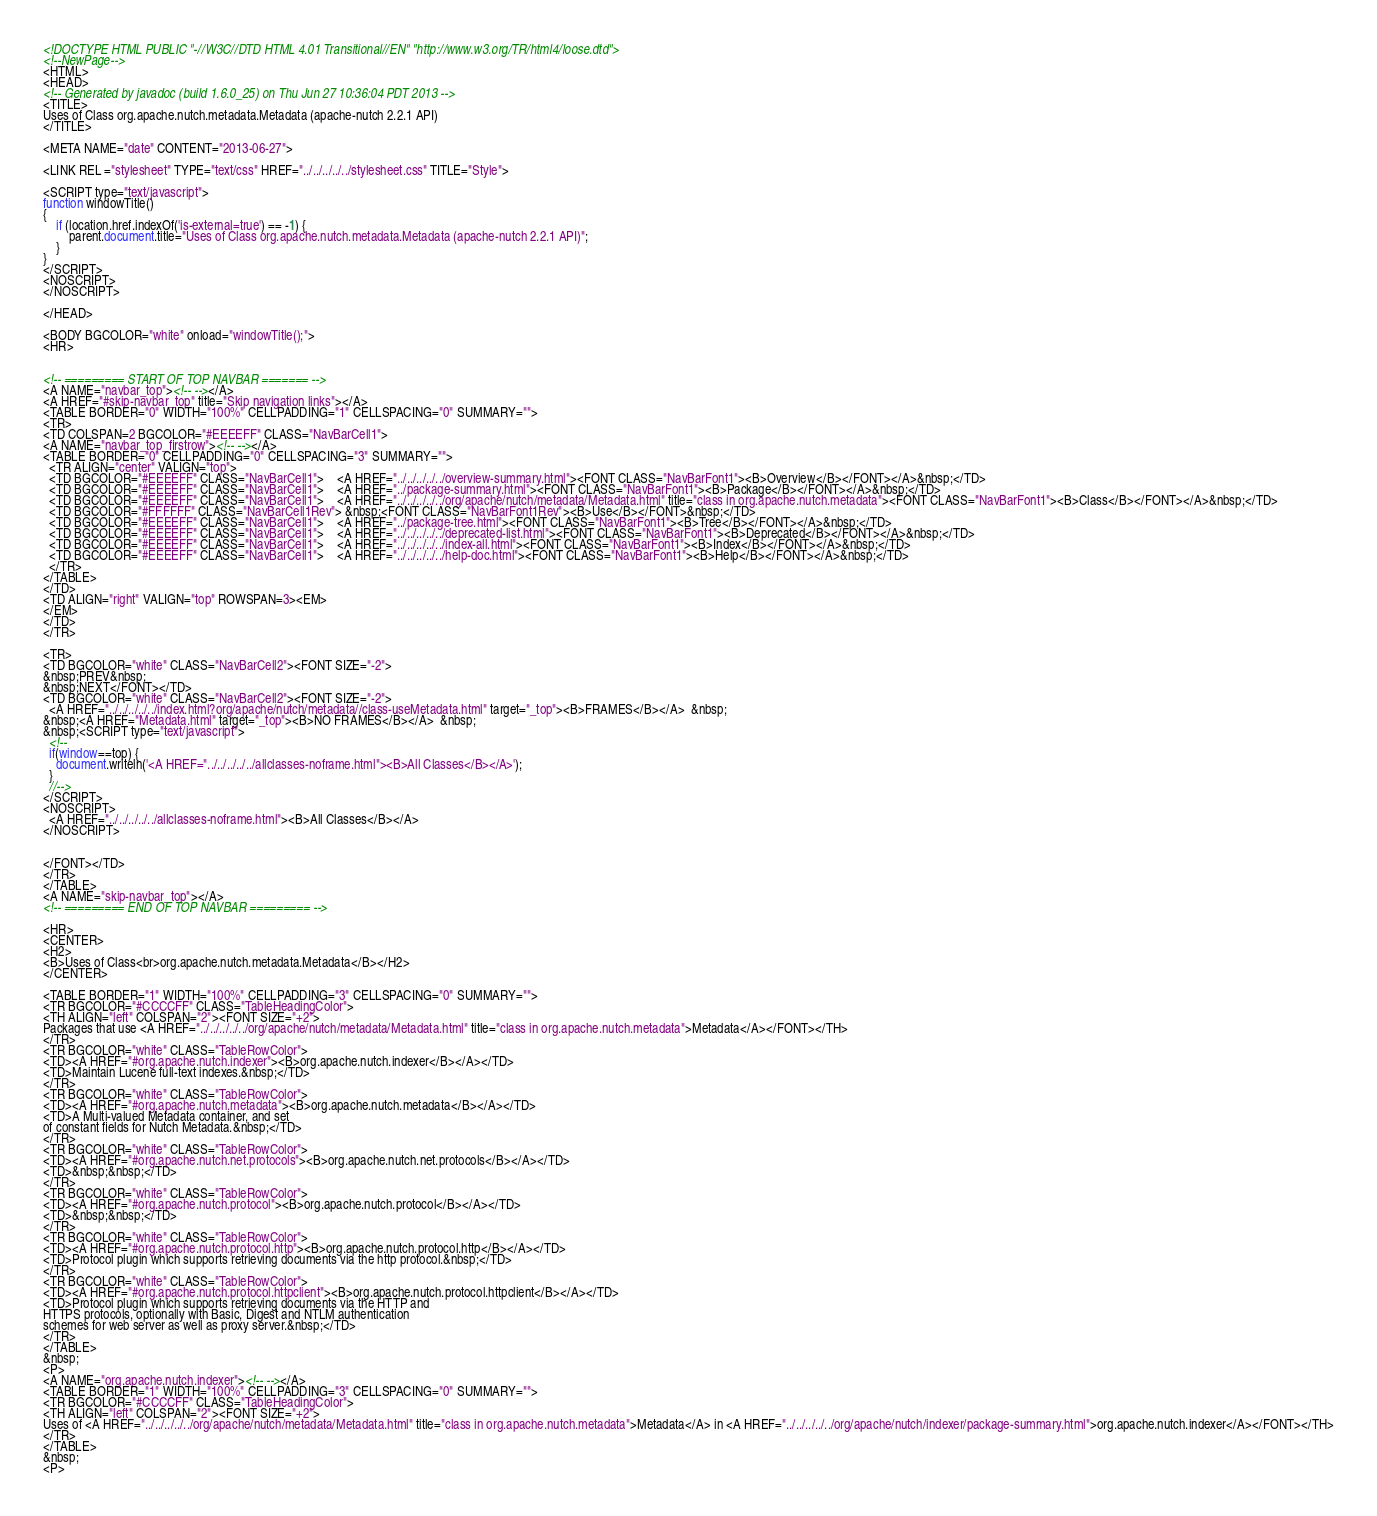<code> <loc_0><loc_0><loc_500><loc_500><_HTML_><!DOCTYPE HTML PUBLIC "-//W3C//DTD HTML 4.01 Transitional//EN" "http://www.w3.org/TR/html4/loose.dtd">
<!--NewPage-->
<HTML>
<HEAD>
<!-- Generated by javadoc (build 1.6.0_25) on Thu Jun 27 10:36:04 PDT 2013 -->
<TITLE>
Uses of Class org.apache.nutch.metadata.Metadata (apache-nutch 2.2.1 API)
</TITLE>

<META NAME="date" CONTENT="2013-06-27">

<LINK REL ="stylesheet" TYPE="text/css" HREF="../../../../../stylesheet.css" TITLE="Style">

<SCRIPT type="text/javascript">
function windowTitle()
{
    if (location.href.indexOf('is-external=true') == -1) {
        parent.document.title="Uses of Class org.apache.nutch.metadata.Metadata (apache-nutch 2.2.1 API)";
    }
}
</SCRIPT>
<NOSCRIPT>
</NOSCRIPT>

</HEAD>

<BODY BGCOLOR="white" onload="windowTitle();">
<HR>


<!-- ========= START OF TOP NAVBAR ======= -->
<A NAME="navbar_top"><!-- --></A>
<A HREF="#skip-navbar_top" title="Skip navigation links"></A>
<TABLE BORDER="0" WIDTH="100%" CELLPADDING="1" CELLSPACING="0" SUMMARY="">
<TR>
<TD COLSPAN=2 BGCOLOR="#EEEEFF" CLASS="NavBarCell1">
<A NAME="navbar_top_firstrow"><!-- --></A>
<TABLE BORDER="0" CELLPADDING="0" CELLSPACING="3" SUMMARY="">
  <TR ALIGN="center" VALIGN="top">
  <TD BGCOLOR="#EEEEFF" CLASS="NavBarCell1">    <A HREF="../../../../../overview-summary.html"><FONT CLASS="NavBarFont1"><B>Overview</B></FONT></A>&nbsp;</TD>
  <TD BGCOLOR="#EEEEFF" CLASS="NavBarCell1">    <A HREF="../package-summary.html"><FONT CLASS="NavBarFont1"><B>Package</B></FONT></A>&nbsp;</TD>
  <TD BGCOLOR="#EEEEFF" CLASS="NavBarCell1">    <A HREF="../../../../../org/apache/nutch/metadata/Metadata.html" title="class in org.apache.nutch.metadata"><FONT CLASS="NavBarFont1"><B>Class</B></FONT></A>&nbsp;</TD>
  <TD BGCOLOR="#FFFFFF" CLASS="NavBarCell1Rev"> &nbsp;<FONT CLASS="NavBarFont1Rev"><B>Use</B></FONT>&nbsp;</TD>
  <TD BGCOLOR="#EEEEFF" CLASS="NavBarCell1">    <A HREF="../package-tree.html"><FONT CLASS="NavBarFont1"><B>Tree</B></FONT></A>&nbsp;</TD>
  <TD BGCOLOR="#EEEEFF" CLASS="NavBarCell1">    <A HREF="../../../../../deprecated-list.html"><FONT CLASS="NavBarFont1"><B>Deprecated</B></FONT></A>&nbsp;</TD>
  <TD BGCOLOR="#EEEEFF" CLASS="NavBarCell1">    <A HREF="../../../../../index-all.html"><FONT CLASS="NavBarFont1"><B>Index</B></FONT></A>&nbsp;</TD>
  <TD BGCOLOR="#EEEEFF" CLASS="NavBarCell1">    <A HREF="../../../../../help-doc.html"><FONT CLASS="NavBarFont1"><B>Help</B></FONT></A>&nbsp;</TD>
  </TR>
</TABLE>
</TD>
<TD ALIGN="right" VALIGN="top" ROWSPAN=3><EM>
</EM>
</TD>
</TR>

<TR>
<TD BGCOLOR="white" CLASS="NavBarCell2"><FONT SIZE="-2">
&nbsp;PREV&nbsp;
&nbsp;NEXT</FONT></TD>
<TD BGCOLOR="white" CLASS="NavBarCell2"><FONT SIZE="-2">
  <A HREF="../../../../../index.html?org/apache/nutch/metadata//class-useMetadata.html" target="_top"><B>FRAMES</B></A>  &nbsp;
&nbsp;<A HREF="Metadata.html" target="_top"><B>NO FRAMES</B></A>  &nbsp;
&nbsp;<SCRIPT type="text/javascript">
  <!--
  if(window==top) {
    document.writeln('<A HREF="../../../../../allclasses-noframe.html"><B>All Classes</B></A>');
  }
  //-->
</SCRIPT>
<NOSCRIPT>
  <A HREF="../../../../../allclasses-noframe.html"><B>All Classes</B></A>
</NOSCRIPT>


</FONT></TD>
</TR>
</TABLE>
<A NAME="skip-navbar_top"></A>
<!-- ========= END OF TOP NAVBAR ========= -->

<HR>
<CENTER>
<H2>
<B>Uses of Class<br>org.apache.nutch.metadata.Metadata</B></H2>
</CENTER>

<TABLE BORDER="1" WIDTH="100%" CELLPADDING="3" CELLSPACING="0" SUMMARY="">
<TR BGCOLOR="#CCCCFF" CLASS="TableHeadingColor">
<TH ALIGN="left" COLSPAN="2"><FONT SIZE="+2">
Packages that use <A HREF="../../../../../org/apache/nutch/metadata/Metadata.html" title="class in org.apache.nutch.metadata">Metadata</A></FONT></TH>
</TR>
<TR BGCOLOR="white" CLASS="TableRowColor">
<TD><A HREF="#org.apache.nutch.indexer"><B>org.apache.nutch.indexer</B></A></TD>
<TD>Maintain Lucene full-text indexes.&nbsp;</TD>
</TR>
<TR BGCOLOR="white" CLASS="TableRowColor">
<TD><A HREF="#org.apache.nutch.metadata"><B>org.apache.nutch.metadata</B></A></TD>
<TD>A Multi-valued Metadata container, and set
of constant fields for Nutch Metadata.&nbsp;</TD>
</TR>
<TR BGCOLOR="white" CLASS="TableRowColor">
<TD><A HREF="#org.apache.nutch.net.protocols"><B>org.apache.nutch.net.protocols</B></A></TD>
<TD>&nbsp;&nbsp;</TD>
</TR>
<TR BGCOLOR="white" CLASS="TableRowColor">
<TD><A HREF="#org.apache.nutch.protocol"><B>org.apache.nutch.protocol</B></A></TD>
<TD>&nbsp;&nbsp;</TD>
</TR>
<TR BGCOLOR="white" CLASS="TableRowColor">
<TD><A HREF="#org.apache.nutch.protocol.http"><B>org.apache.nutch.protocol.http</B></A></TD>
<TD>Protocol plugin which supports retrieving documents via the http protocol.&nbsp;</TD>
</TR>
<TR BGCOLOR="white" CLASS="TableRowColor">
<TD><A HREF="#org.apache.nutch.protocol.httpclient"><B>org.apache.nutch.protocol.httpclient</B></A></TD>
<TD>Protocol plugin which supports retrieving documents via the HTTP and
HTTPS protocols, optionally with Basic, Digest and NTLM authentication
schemes for web server as well as proxy server.&nbsp;</TD>
</TR>
</TABLE>
&nbsp;
<P>
<A NAME="org.apache.nutch.indexer"><!-- --></A>
<TABLE BORDER="1" WIDTH="100%" CELLPADDING="3" CELLSPACING="0" SUMMARY="">
<TR BGCOLOR="#CCCCFF" CLASS="TableHeadingColor">
<TH ALIGN="left" COLSPAN="2"><FONT SIZE="+2">
Uses of <A HREF="../../../../../org/apache/nutch/metadata/Metadata.html" title="class in org.apache.nutch.metadata">Metadata</A> in <A HREF="../../../../../org/apache/nutch/indexer/package-summary.html">org.apache.nutch.indexer</A></FONT></TH>
</TR>
</TABLE>
&nbsp;
<P>
</code> 